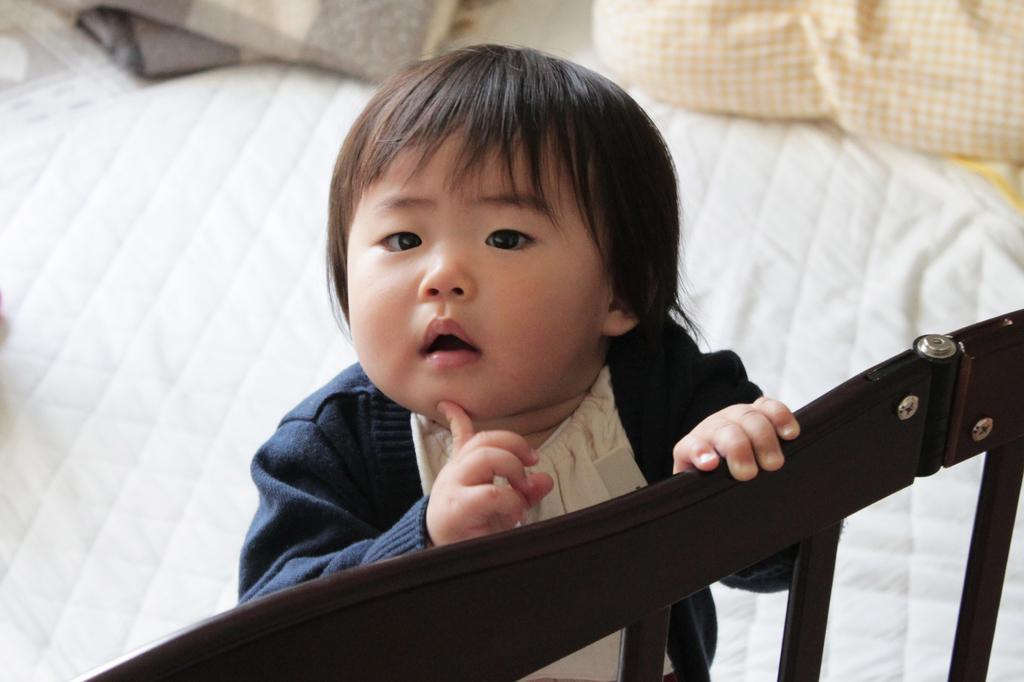Describe this image in one or two sentences. In this picture we can see a boy standing on bed sheet and holding wooden fence with his hand and in the background we can see pillow, floor. 